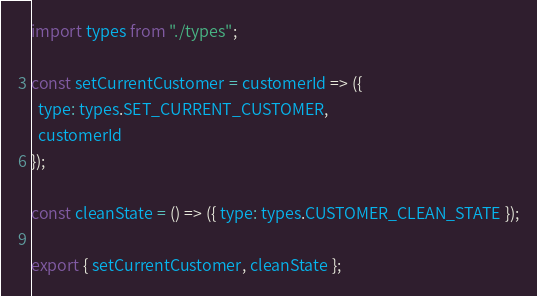<code> <loc_0><loc_0><loc_500><loc_500><_JavaScript_>import types from "./types";

const setCurrentCustomer = customerId => ({
  type: types.SET_CURRENT_CUSTOMER,
  customerId
});

const cleanState = () => ({ type: types.CUSTOMER_CLEAN_STATE });

export { setCurrentCustomer, cleanState };
</code> 